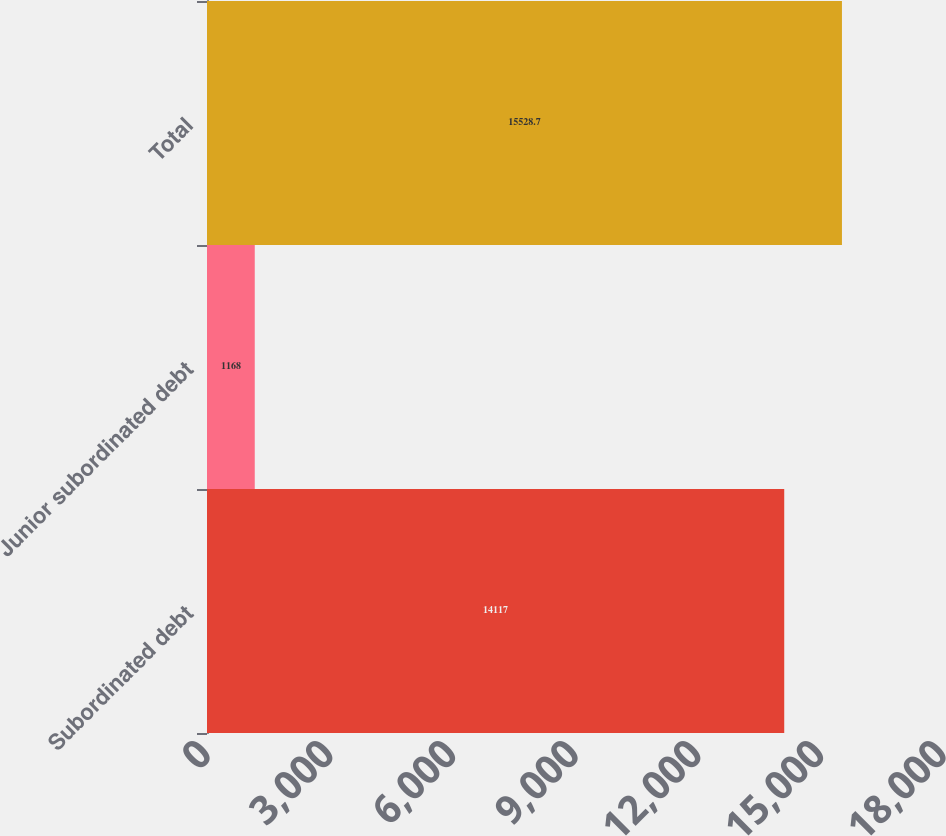<chart> <loc_0><loc_0><loc_500><loc_500><bar_chart><fcel>Subordinated debt<fcel>Junior subordinated debt<fcel>Total<nl><fcel>14117<fcel>1168<fcel>15528.7<nl></chart> 